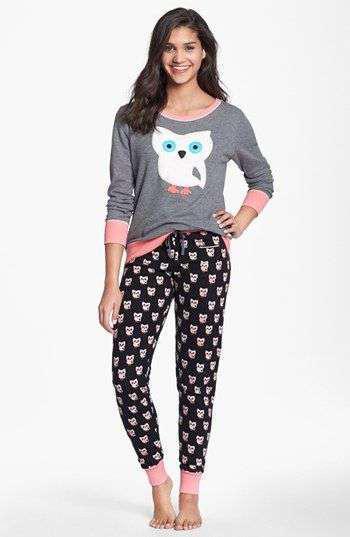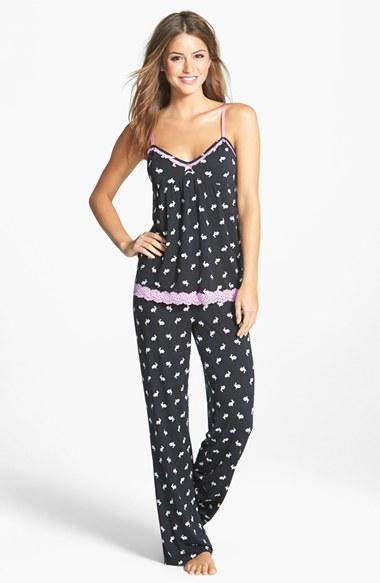The first image is the image on the left, the second image is the image on the right. Given the left and right images, does the statement "All models face forward and wear long pants, and at least one model wears dark pants with an all-over print." hold true? Answer yes or no. Yes. The first image is the image on the left, the second image is the image on the right. Examine the images to the left and right. Is the description "Two pajama models are facing front and shown full length, each striking a pose similar to the other person." accurate? Answer yes or no. Yes. 